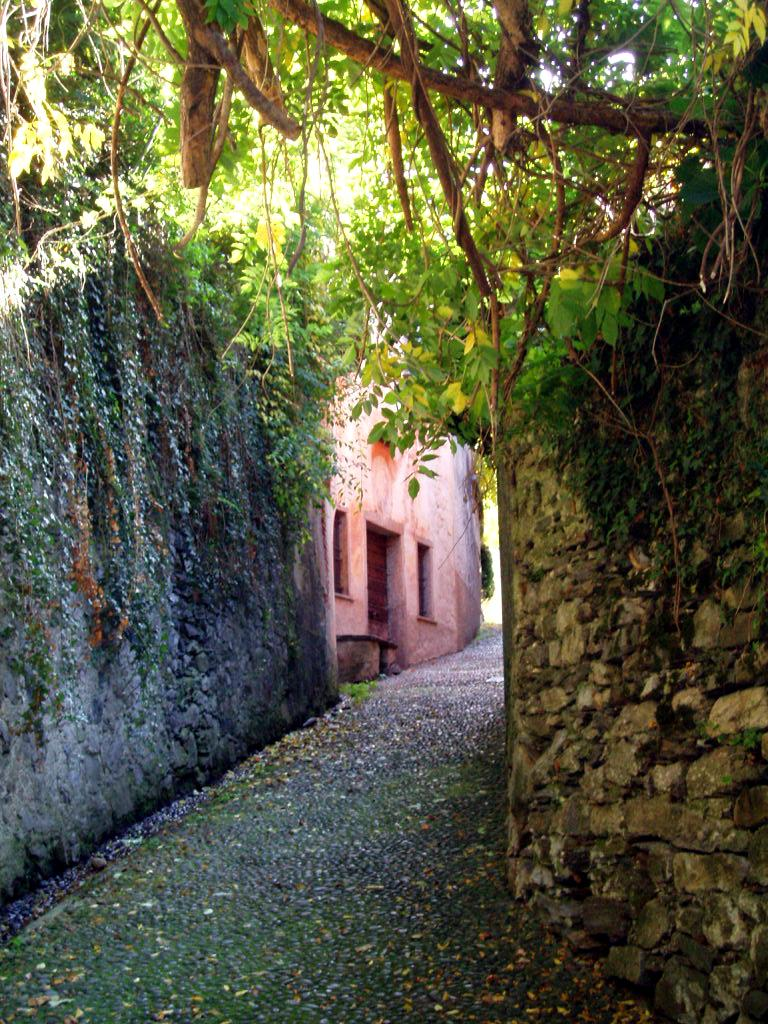What type of structure is visible in the image? There is a house in the image. What is located near the house? There is a wall in the image. What type of vegetation can be seen in the image? There are trees in the image. Can you see a snail climbing the wall in the image? There is no snail visible in the image. How many times does the twig jump in the image? There is no twig present in the image, so it cannot jump. 